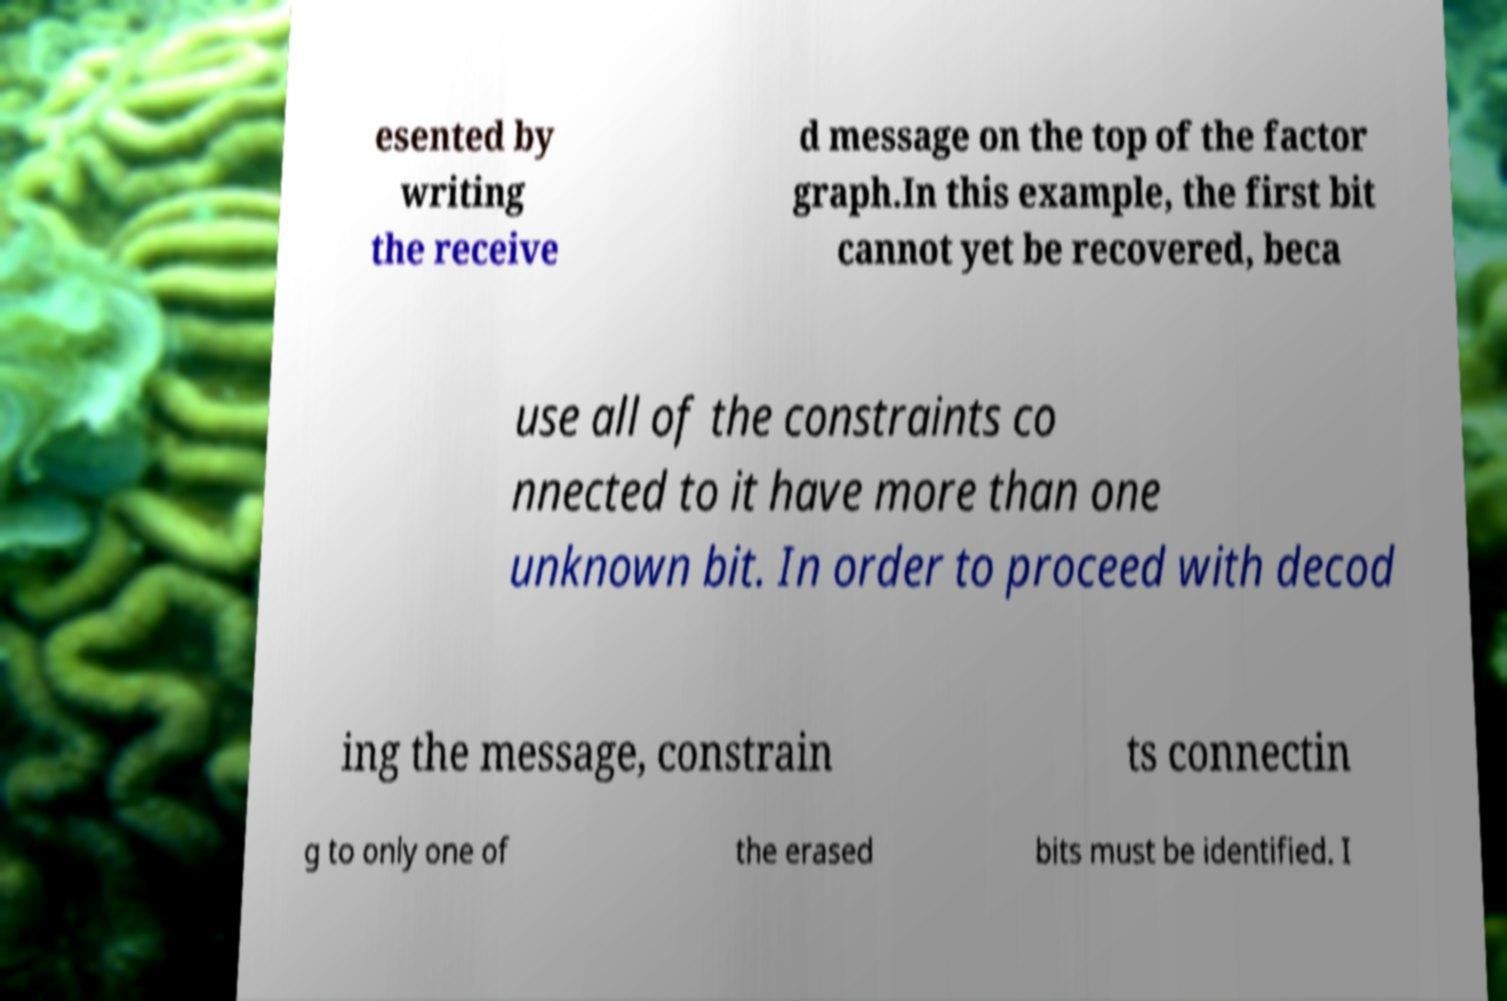Please identify and transcribe the text found in this image. esented by writing the receive d message on the top of the factor graph.In this example, the first bit cannot yet be recovered, beca use all of the constraints co nnected to it have more than one unknown bit. In order to proceed with decod ing the message, constrain ts connectin g to only one of the erased bits must be identified. I 